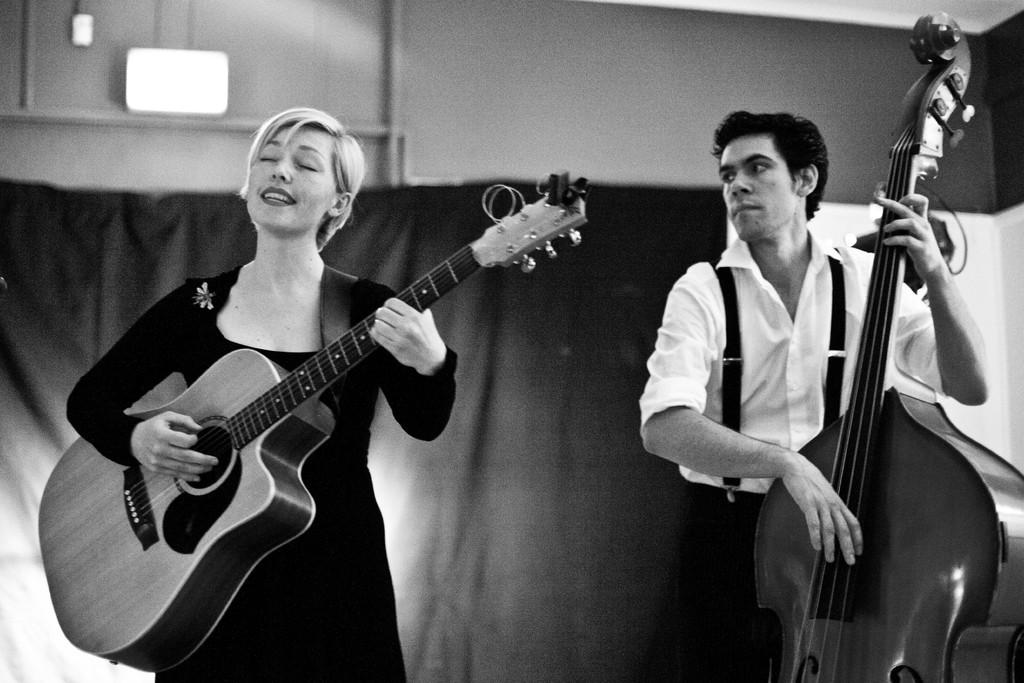What is the color scheme of the image? The image is black and white. What can be seen in the background of the image? There is a wall and a curtain in the background of the image. How many people are in the image? There are two people in the image, a man and a woman. What are the man and woman doing in the image? The man and woman are standing and playing musical instruments. What type of cushion is being used by the vegetable in the image? There are no vegetables or cushions present in the image. Can you hear any noise coming from the image? The image is a still photograph, so there is no sound or noise present. 